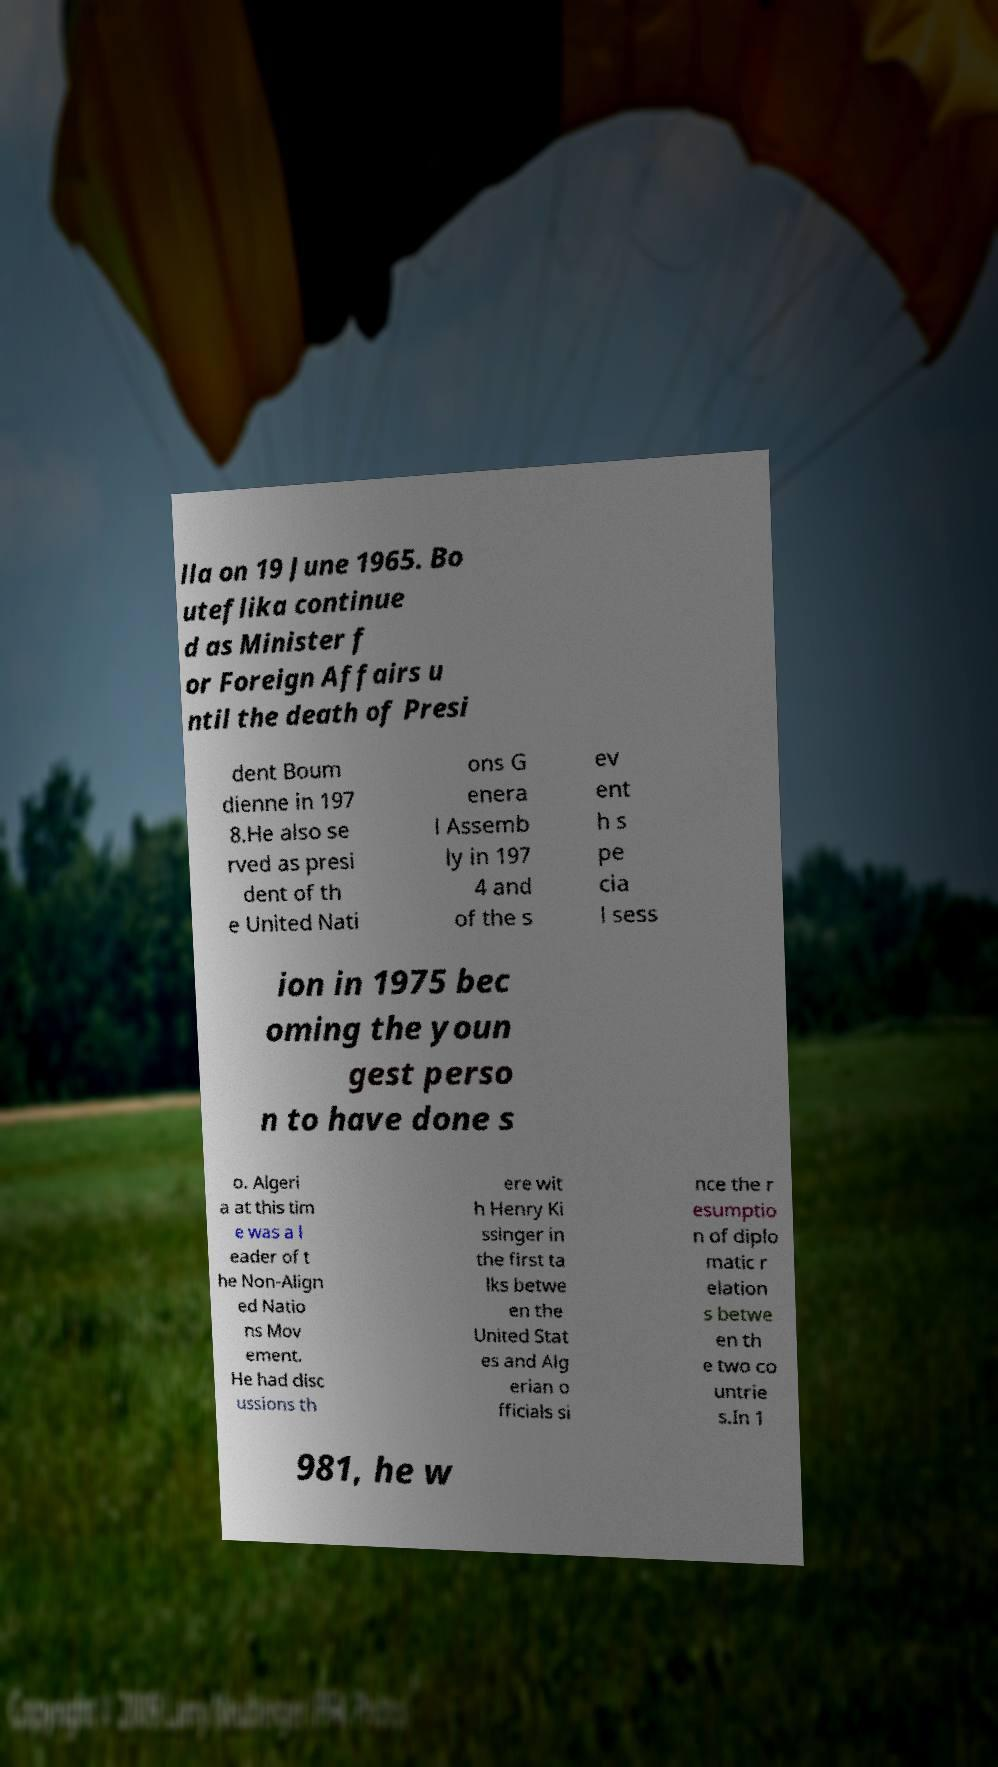What messages or text are displayed in this image? I need them in a readable, typed format. lla on 19 June 1965. Bo uteflika continue d as Minister f or Foreign Affairs u ntil the death of Presi dent Boum dienne in 197 8.He also se rved as presi dent of th e United Nati ons G enera l Assemb ly in 197 4 and of the s ev ent h s pe cia l sess ion in 1975 bec oming the youn gest perso n to have done s o. Algeri a at this tim e was a l eader of t he Non-Align ed Natio ns Mov ement. He had disc ussions th ere wit h Henry Ki ssinger in the first ta lks betwe en the United Stat es and Alg erian o fficials si nce the r esumptio n of diplo matic r elation s betwe en th e two co untrie s.In 1 981, he w 